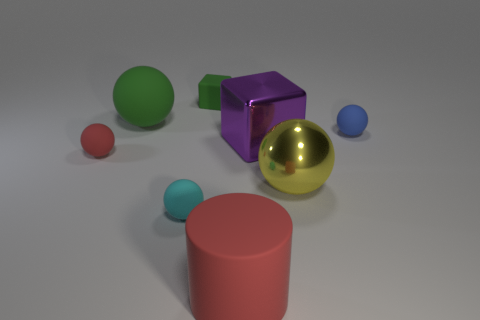Subtract all small red rubber spheres. How many spheres are left? 4 Subtract all green spheres. How many spheres are left? 4 Add 2 big yellow rubber things. How many objects exist? 10 Subtract all blocks. How many objects are left? 6 Subtract 1 blocks. How many blocks are left? 1 Subtract all cyan cylinders. Subtract all yellow blocks. How many cylinders are left? 1 Subtract all gray cylinders. How many gray cubes are left? 0 Subtract all purple metallic cylinders. Subtract all blue balls. How many objects are left? 7 Add 8 tiny cyan spheres. How many tiny cyan spheres are left? 9 Add 5 cylinders. How many cylinders exist? 6 